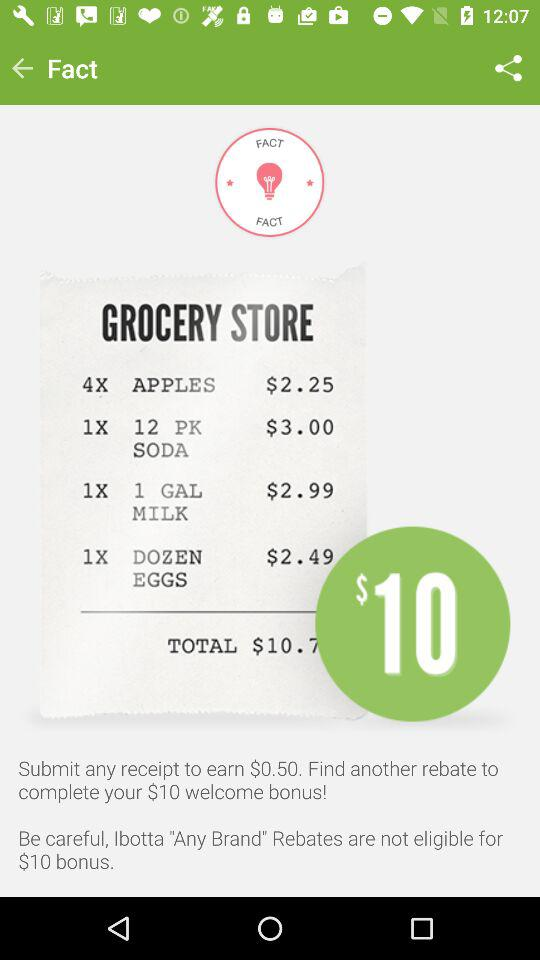What is the price of "12 PK SODA"?
Answer the question using a single word or phrase. The price of "12 PK SODA" is $3.00 